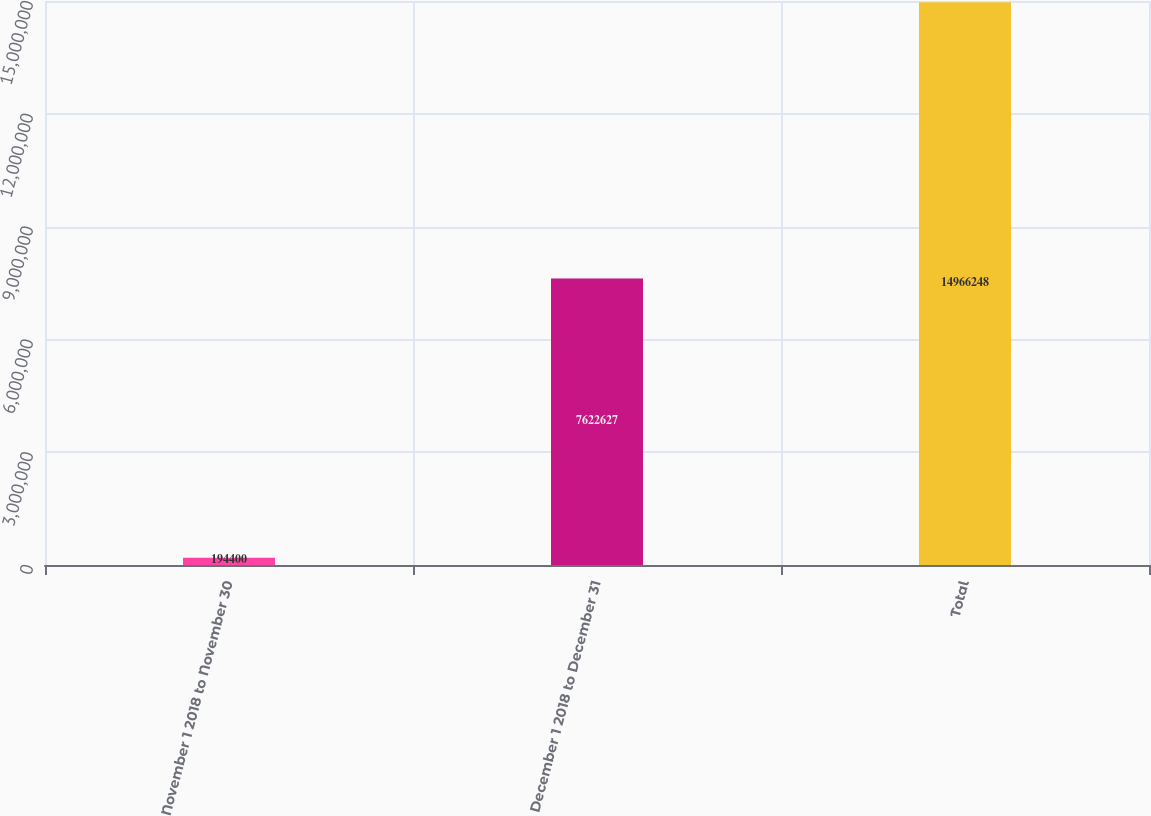<chart> <loc_0><loc_0><loc_500><loc_500><bar_chart><fcel>November 1 2018 to November 30<fcel>December 1 2018 to December 31<fcel>Total<nl><fcel>194400<fcel>7.62263e+06<fcel>1.49662e+07<nl></chart> 